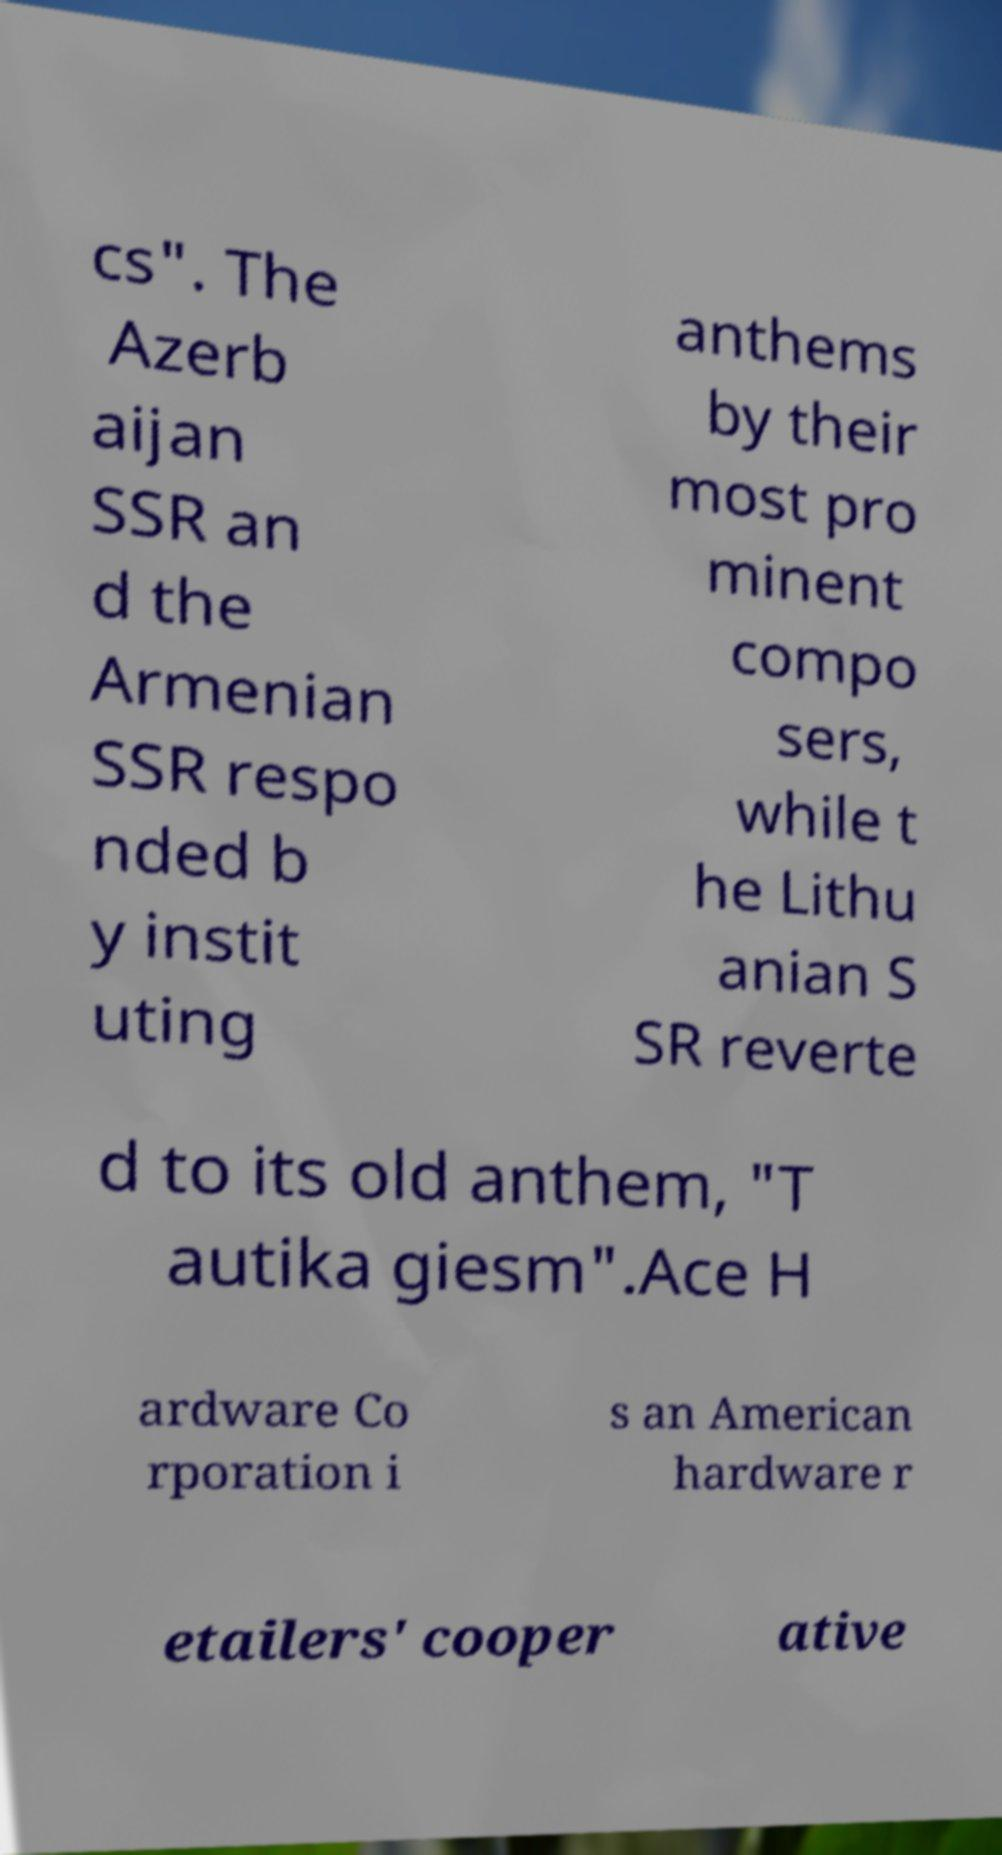Please read and relay the text visible in this image. What does it say? cs". The Azerb aijan SSR an d the Armenian SSR respo nded b y instit uting anthems by their most pro minent compo sers, while t he Lithu anian S SR reverte d to its old anthem, "T autika giesm".Ace H ardware Co rporation i s an American hardware r etailers' cooper ative 